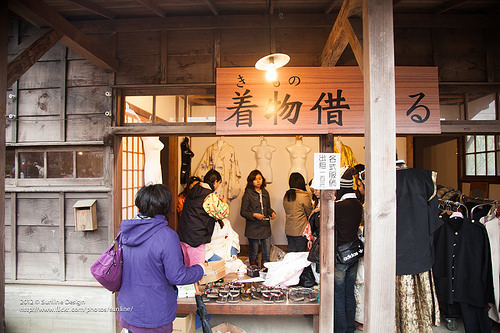<image>
Can you confirm if the sign is behind the woman? No. The sign is not behind the woman. From this viewpoint, the sign appears to be positioned elsewhere in the scene. Is there a birdhouse above the purse? No. The birdhouse is not positioned above the purse. The vertical arrangement shows a different relationship. 